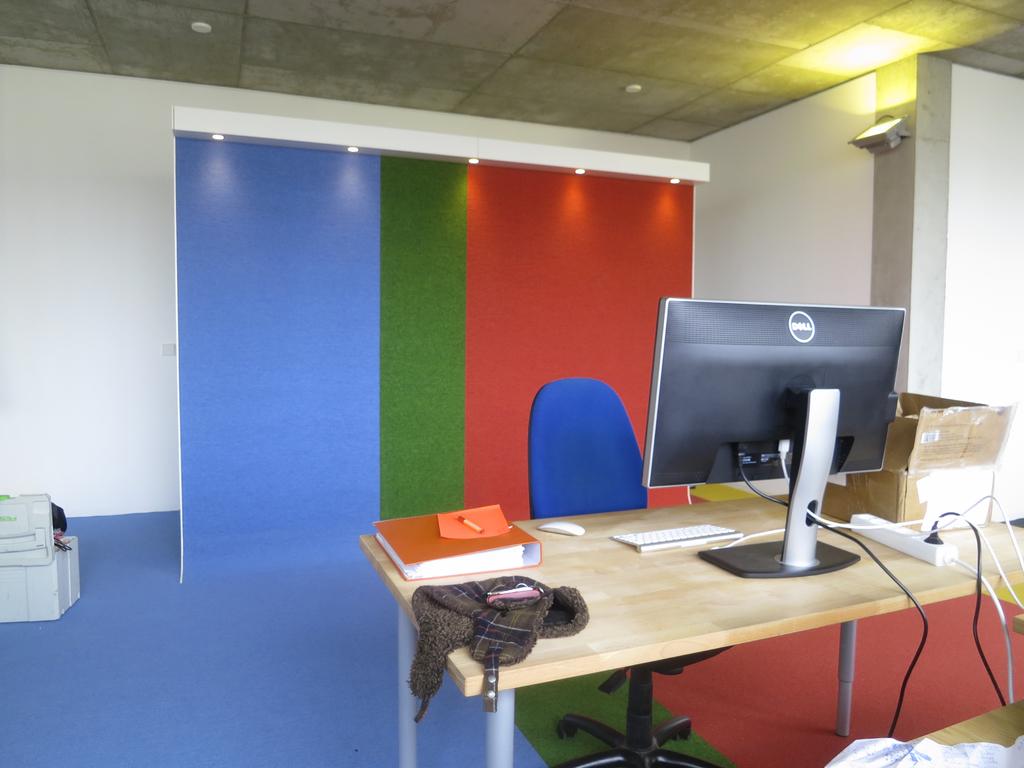What is the brand of the computer monitor?
Your answer should be compact. Dell. 